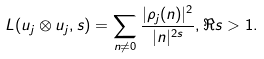<formula> <loc_0><loc_0><loc_500><loc_500>L ( u _ { j } \otimes u _ { j } , s ) = \sum _ { n \neq 0 } \frac { | \rho _ { j } ( n ) | ^ { 2 } } { | n | ^ { 2 s } } , \Re { s } > 1 .</formula> 